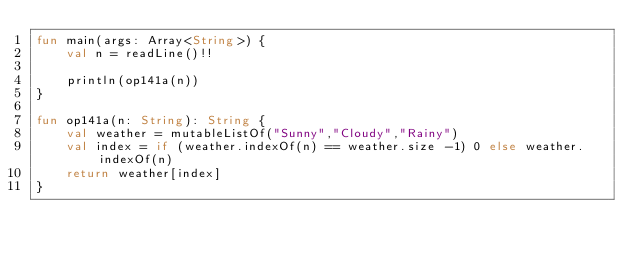Convert code to text. <code><loc_0><loc_0><loc_500><loc_500><_Kotlin_>fun main(args: Array<String>) {
    val n = readLine()!!

    println(op141a(n))
}

fun op141a(n: String): String {
    val weather = mutableListOf("Sunny","Cloudy","Rainy")
    val index = if (weather.indexOf(n) == weather.size -1) 0 else weather.indexOf(n)
    return weather[index]
}


</code> 